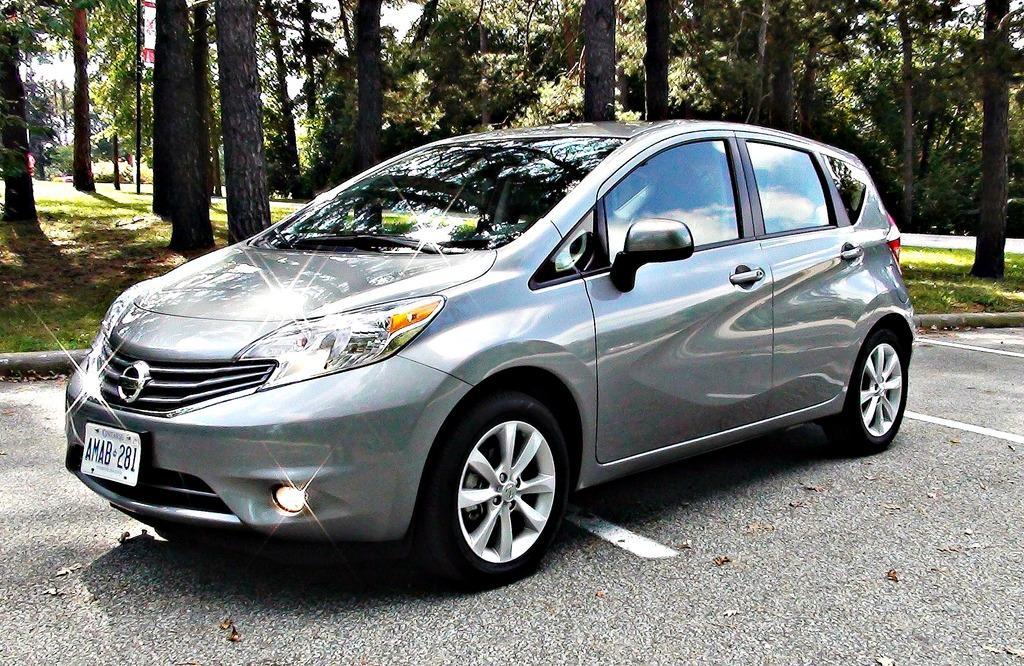Please provide a concise description of this image. In this image we can see a car on the road. We can see the grass, tree trunks and the sky. 